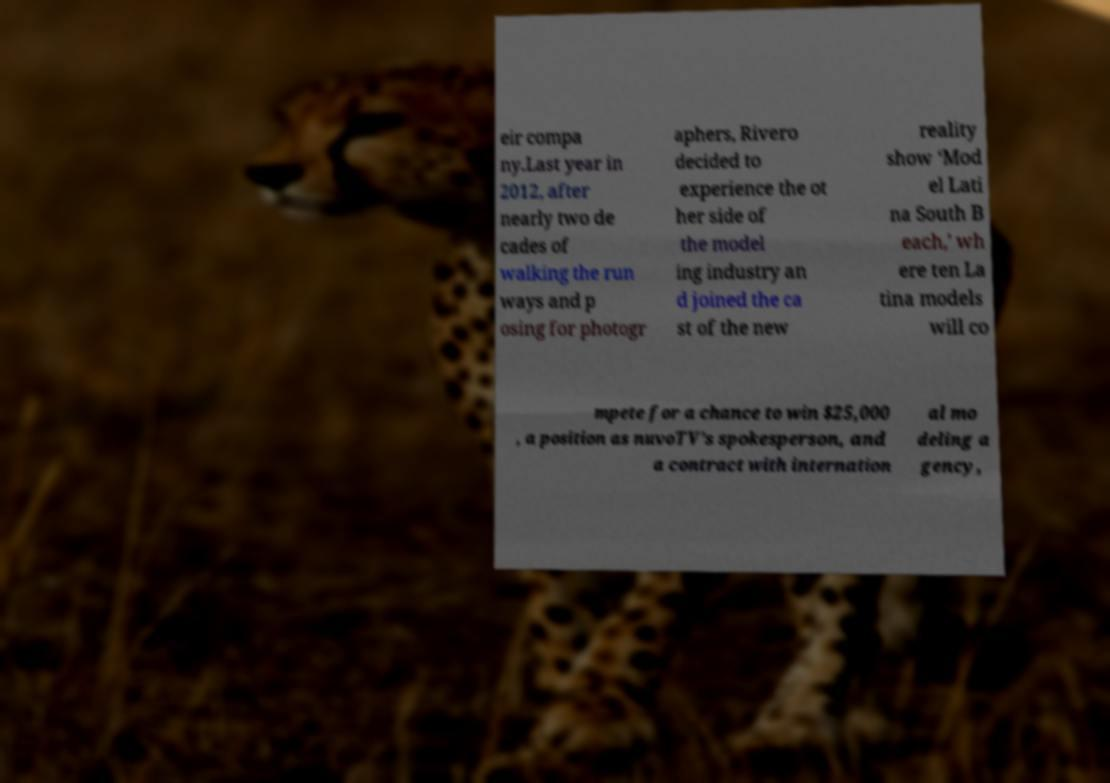Could you assist in decoding the text presented in this image and type it out clearly? eir compa ny.Last year in 2012, after nearly two de cades of walking the run ways and p osing for photogr aphers, Rivero decided to experience the ot her side of the model ing industry an d joined the ca st of the new reality show ‘Mod el Lati na South B each,’ wh ere ten La tina models will co mpete for a chance to win $25,000 , a position as nuvoTV’s spokesperson, and a contract with internation al mo deling a gency, 